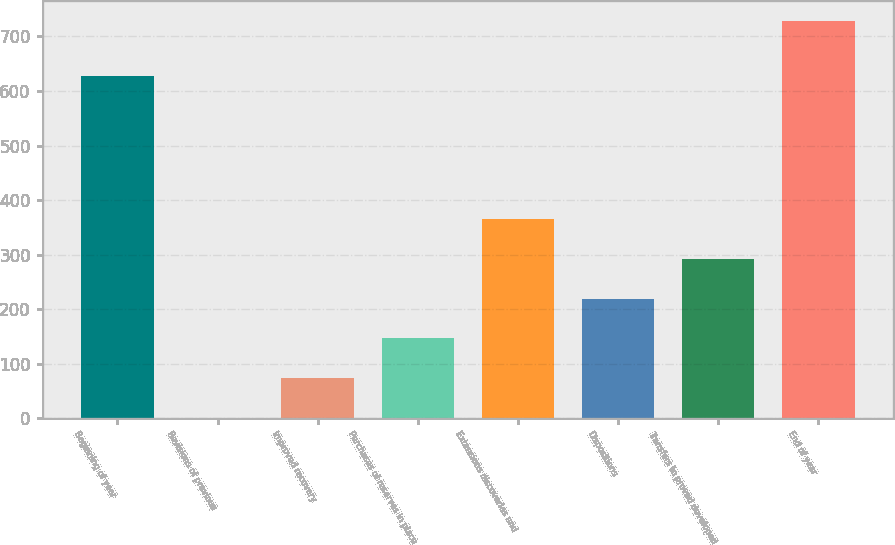Convert chart. <chart><loc_0><loc_0><loc_500><loc_500><bar_chart><fcel>Beginning of year<fcel>Revisions of previous<fcel>Improved recovery<fcel>Purchases of reserves in place<fcel>Extensions discoveries and<fcel>Dispositions<fcel>Transfers to proved developed<fcel>End of year<nl><fcel>627<fcel>1<fcel>73.7<fcel>146.4<fcel>364.5<fcel>219.1<fcel>291.8<fcel>728<nl></chart> 